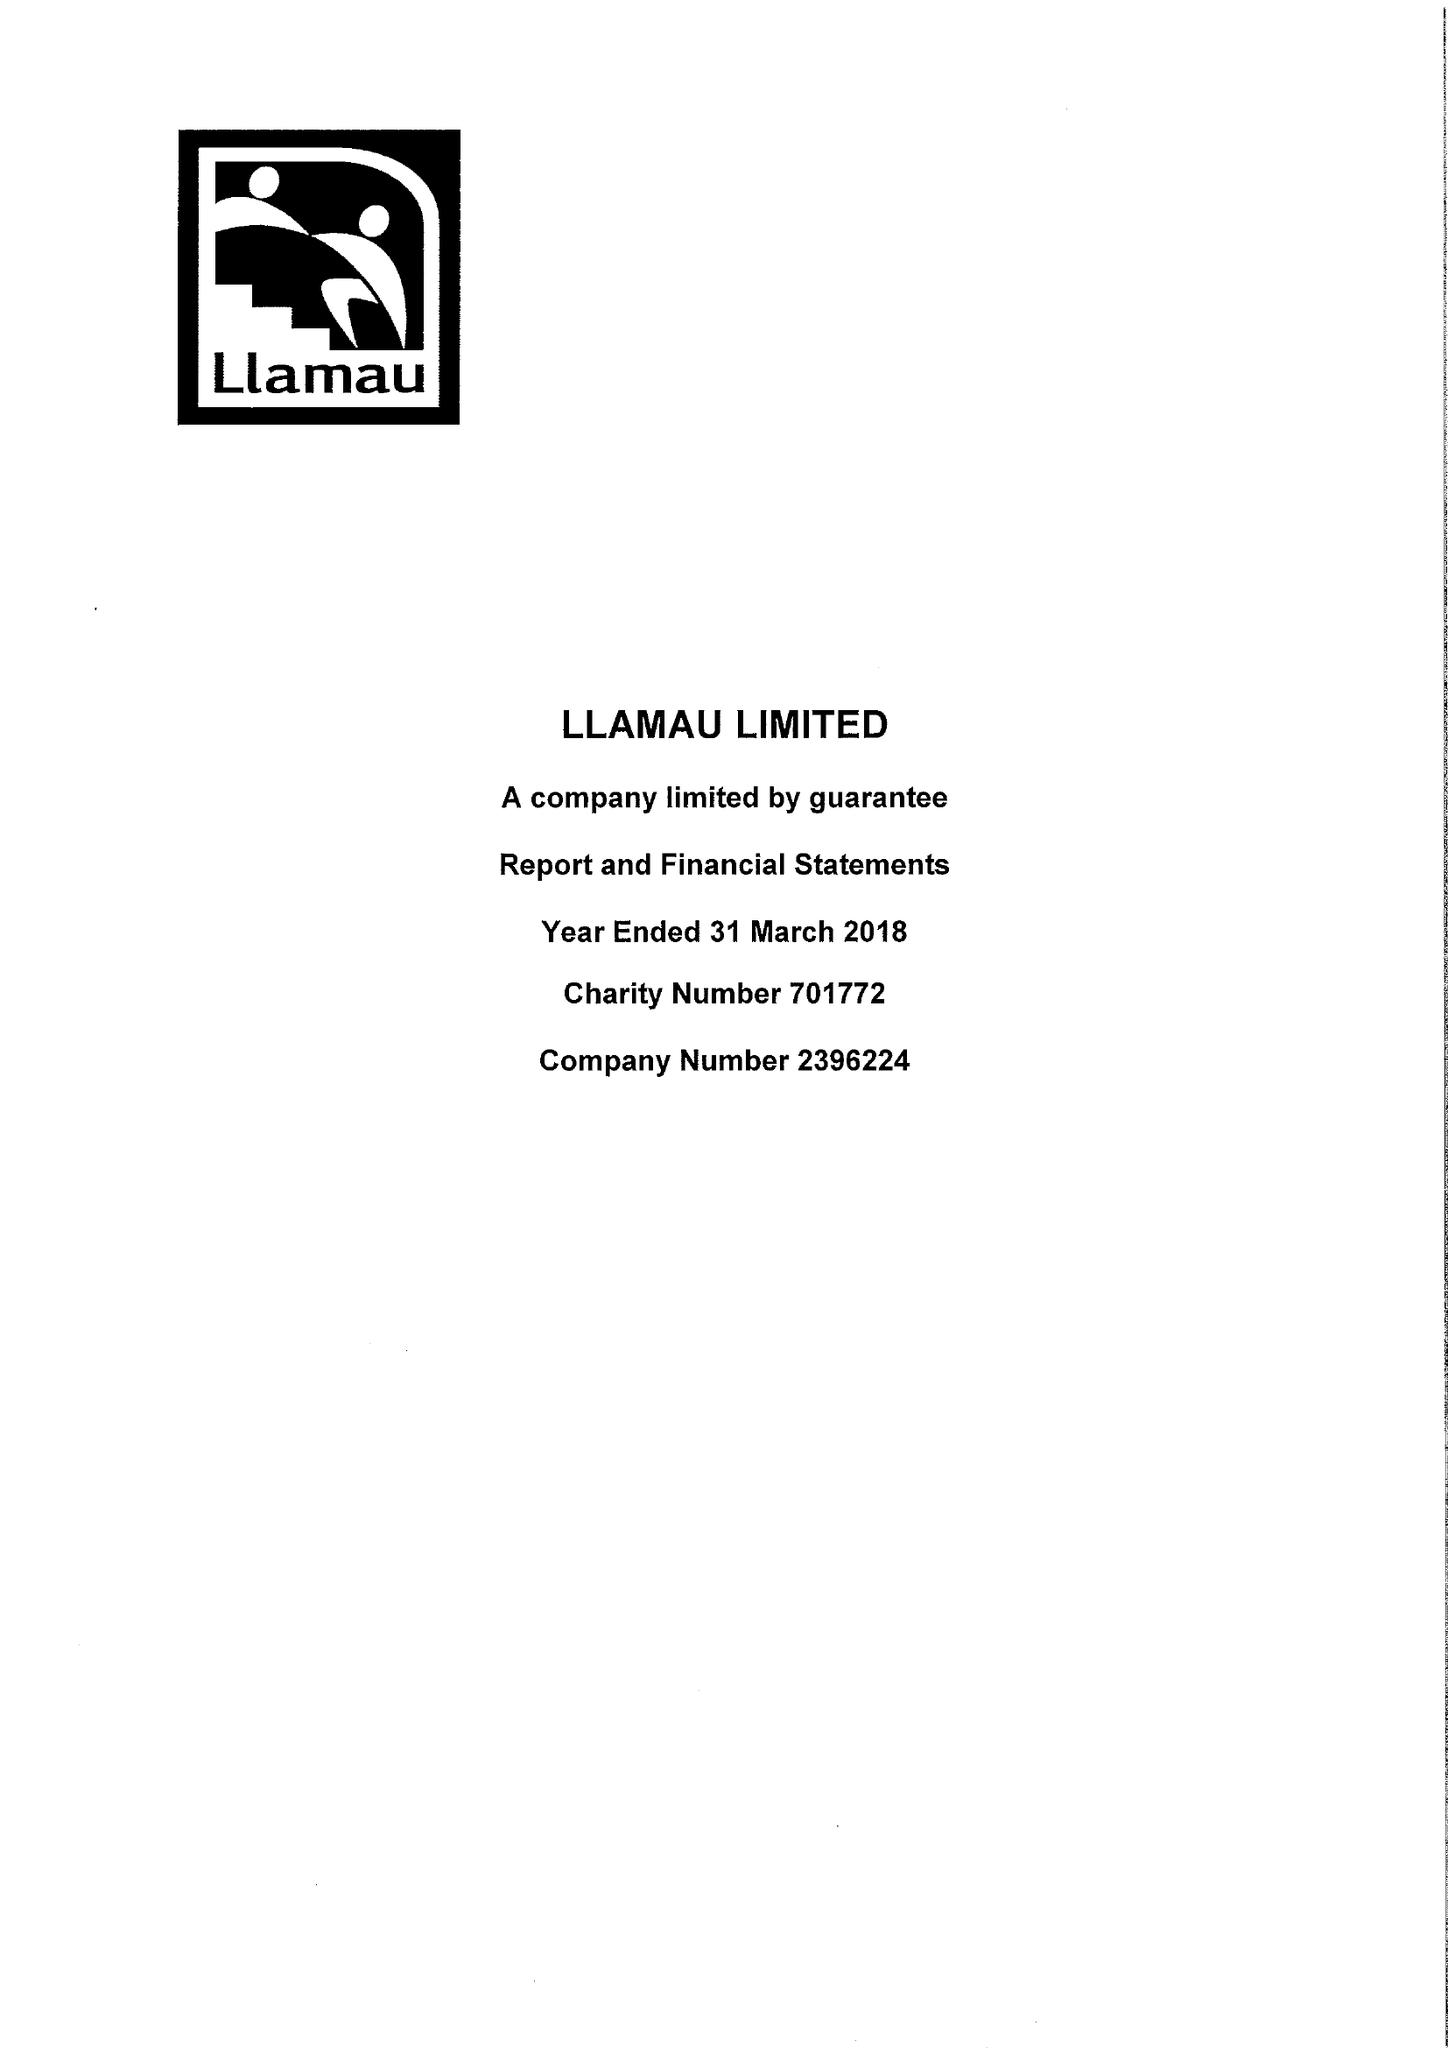What is the value for the address__post_town?
Answer the question using a single word or phrase. CARDIFF 